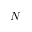Convert formula to latex. <formula><loc_0><loc_0><loc_500><loc_500>N</formula> 